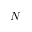Convert formula to latex. <formula><loc_0><loc_0><loc_500><loc_500>N</formula> 